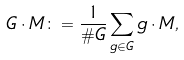Convert formula to latex. <formula><loc_0><loc_0><loc_500><loc_500>G \cdot M \colon = \frac { 1 } { \# G } \sum _ { g \in G } g \cdot M ,</formula> 